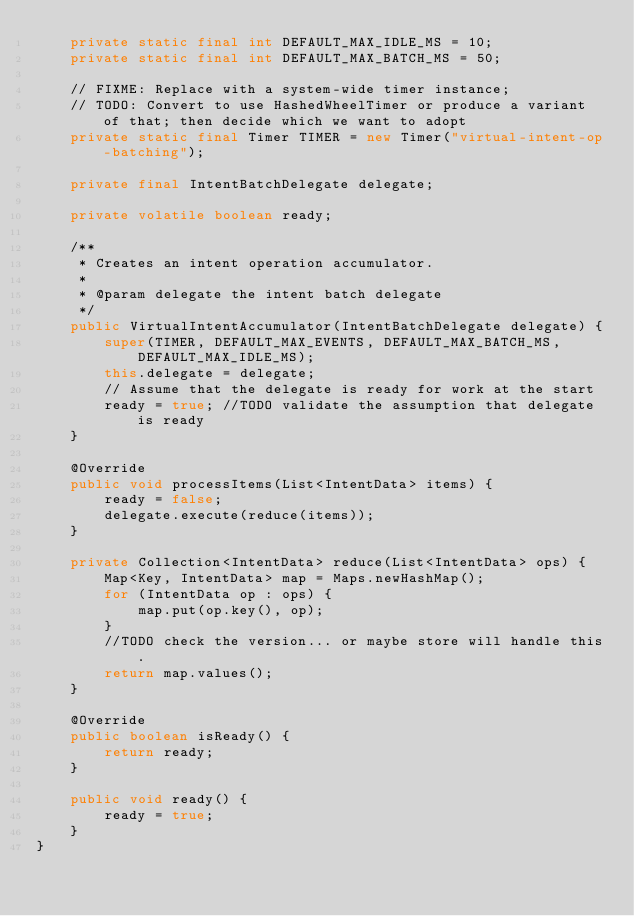Convert code to text. <code><loc_0><loc_0><loc_500><loc_500><_Java_>    private static final int DEFAULT_MAX_IDLE_MS = 10;
    private static final int DEFAULT_MAX_BATCH_MS = 50;

    // FIXME: Replace with a system-wide timer instance;
    // TODO: Convert to use HashedWheelTimer or produce a variant of that; then decide which we want to adopt
    private static final Timer TIMER = new Timer("virtual-intent-op-batching");

    private final IntentBatchDelegate delegate;

    private volatile boolean ready;

    /**
     * Creates an intent operation accumulator.
     *
     * @param delegate the intent batch delegate
     */
    public VirtualIntentAccumulator(IntentBatchDelegate delegate) {
        super(TIMER, DEFAULT_MAX_EVENTS, DEFAULT_MAX_BATCH_MS, DEFAULT_MAX_IDLE_MS);
        this.delegate = delegate;
        // Assume that the delegate is ready for work at the start
        ready = true; //TODO validate the assumption that delegate is ready
    }

    @Override
    public void processItems(List<IntentData> items) {
        ready = false;
        delegate.execute(reduce(items));
    }

    private Collection<IntentData> reduce(List<IntentData> ops) {
        Map<Key, IntentData> map = Maps.newHashMap();
        for (IntentData op : ops) {
            map.put(op.key(), op);
        }
        //TODO check the version... or maybe store will handle this.
        return map.values();
    }

    @Override
    public boolean isReady() {
        return ready;
    }

    public void ready() {
        ready = true;
    }
}
</code> 